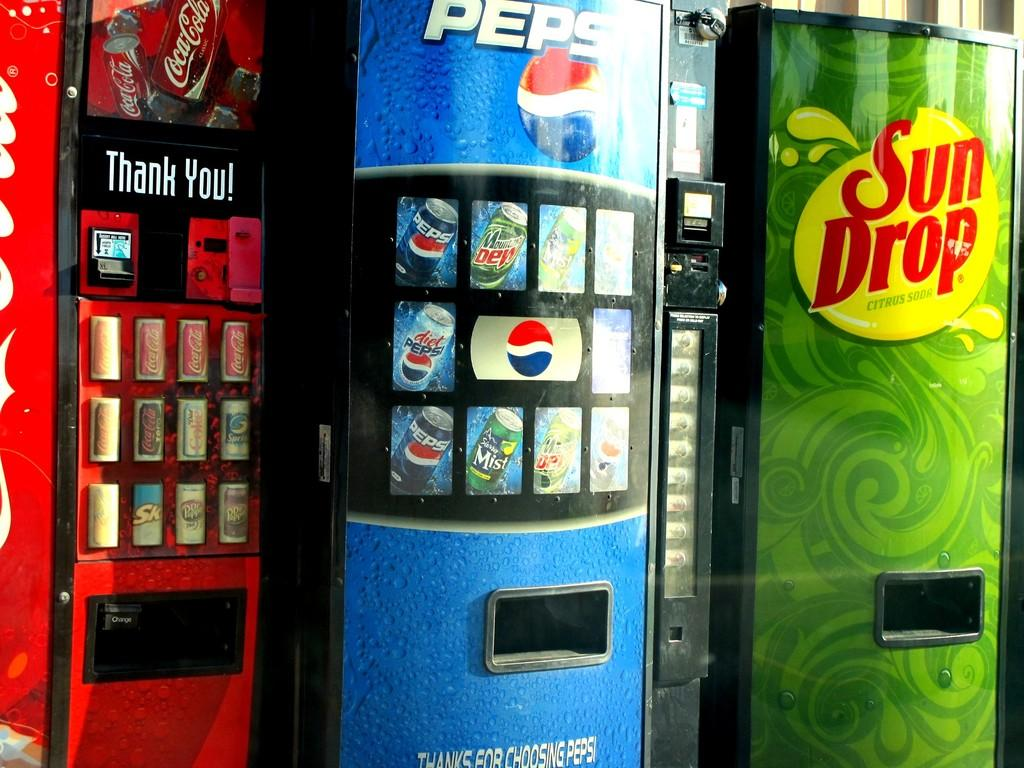<image>
Create a compact narrative representing the image presented. A Pepsi vending machine is next to a Sun Drop machine and a Coca-Cola machine. 